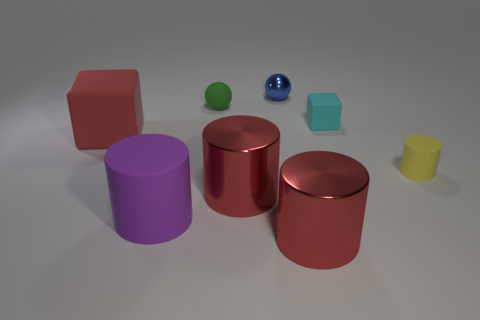There is a rubber block behind the large red object behind the yellow thing; how big is it? The small blue rubber block located behind the large red cylinder, which is in turn behind the yellow cylinder, is relatively small in size compared to the other objects. Its dimensions appear to be roughly one-third the height of the yellow cylinder and about half the size of the green sphere. 